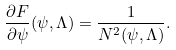Convert formula to latex. <formula><loc_0><loc_0><loc_500><loc_500>\frac { \partial F } { \partial \psi } ( \psi , \Lambda ) = \frac { 1 } { N ^ { 2 } ( \psi , \Lambda ) } .</formula> 